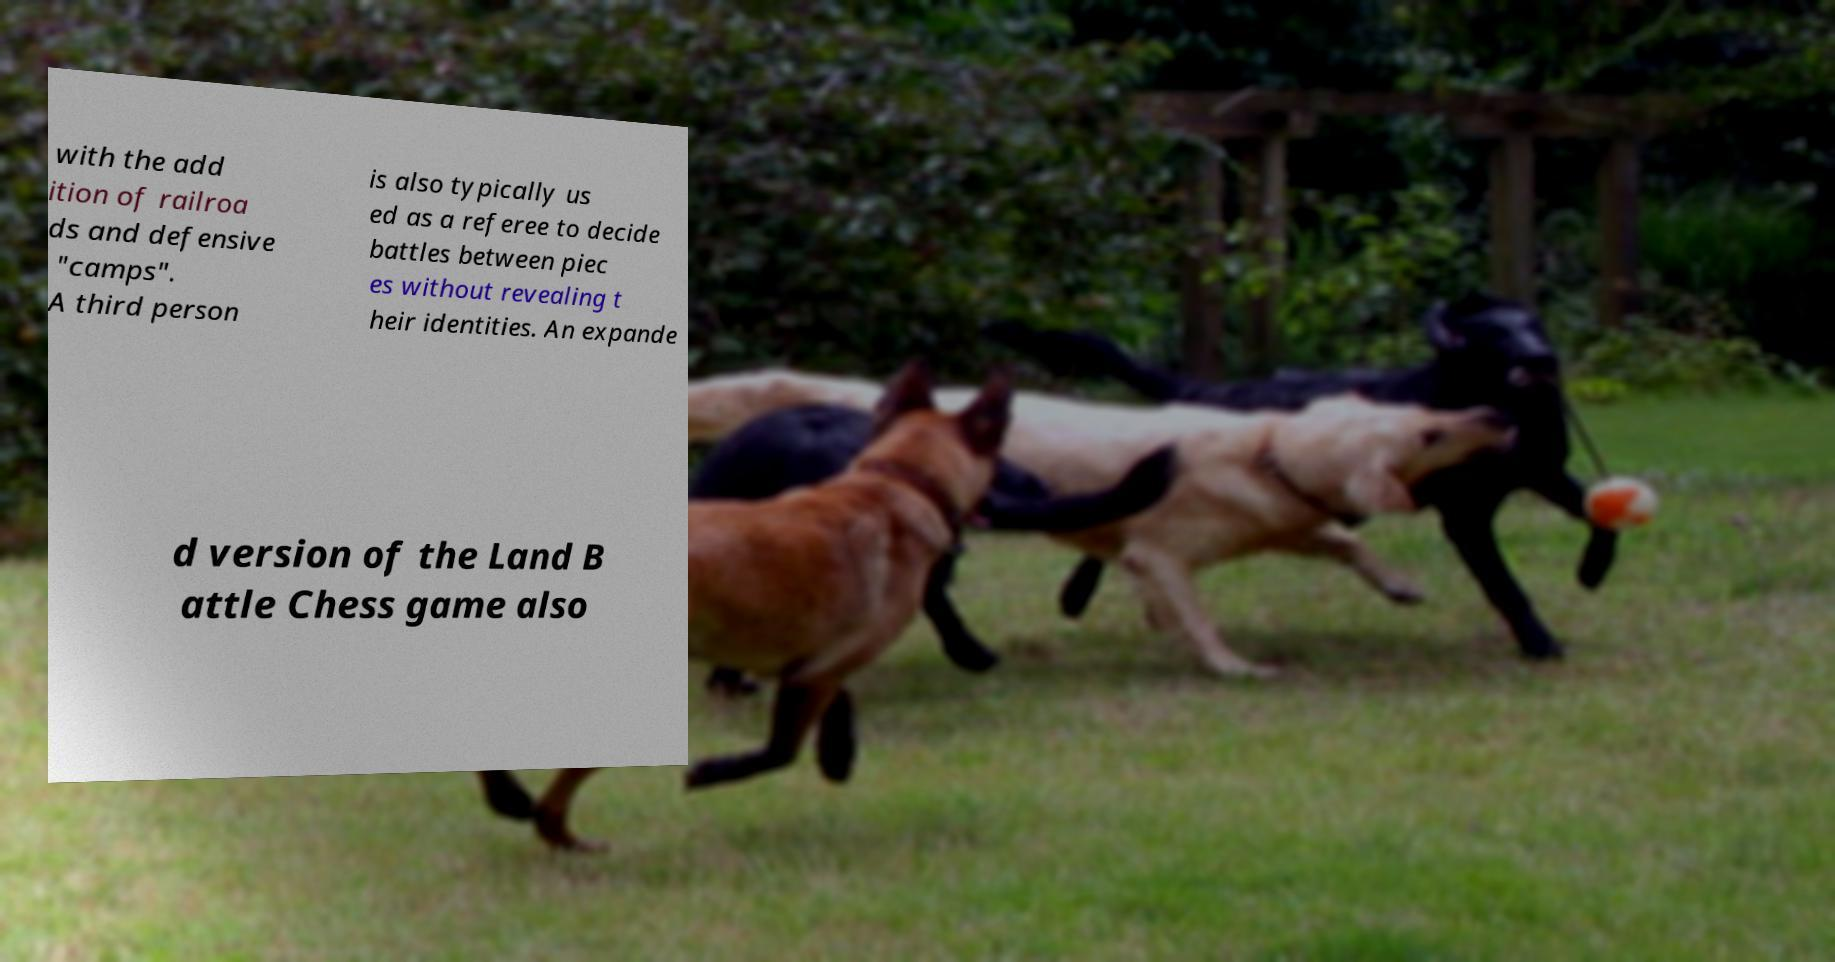Please identify and transcribe the text found in this image. with the add ition of railroa ds and defensive "camps". A third person is also typically us ed as a referee to decide battles between piec es without revealing t heir identities. An expande d version of the Land B attle Chess game also 